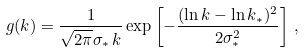<formula> <loc_0><loc_0><loc_500><loc_500>g ( k ) = \frac { 1 } { \sqrt { 2 \pi } \sigma _ { * } \, k } \exp \left [ - \frac { ( \ln k - \ln k _ { * } ) ^ { 2 } } { 2 \sigma _ { * } ^ { 2 } } \right ] \, ,</formula> 